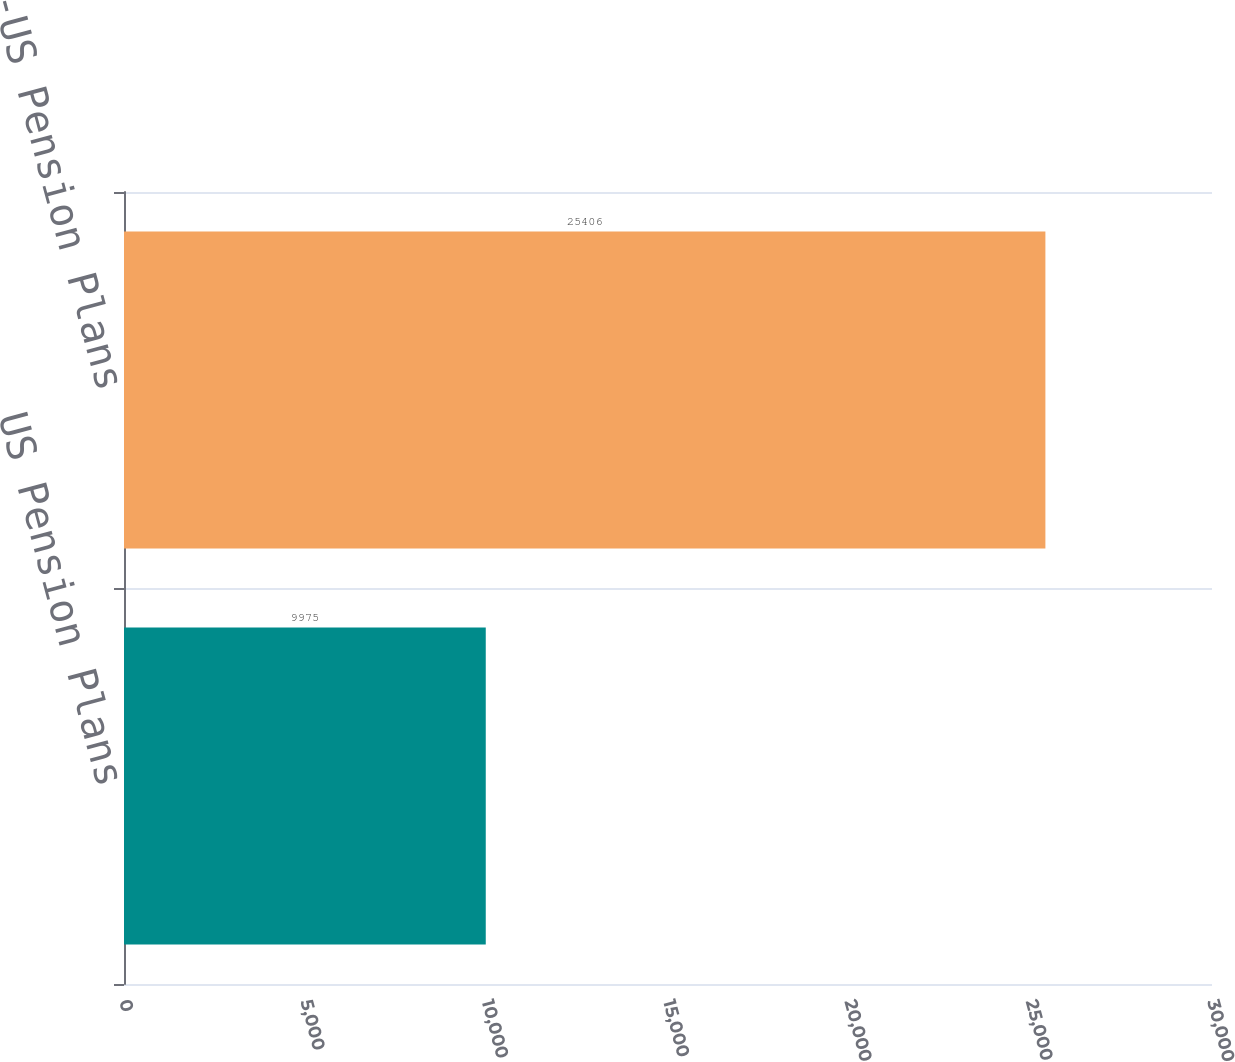Convert chart to OTSL. <chart><loc_0><loc_0><loc_500><loc_500><bar_chart><fcel>US Pension Plans<fcel>Non-US Pension Plans<nl><fcel>9975<fcel>25406<nl></chart> 